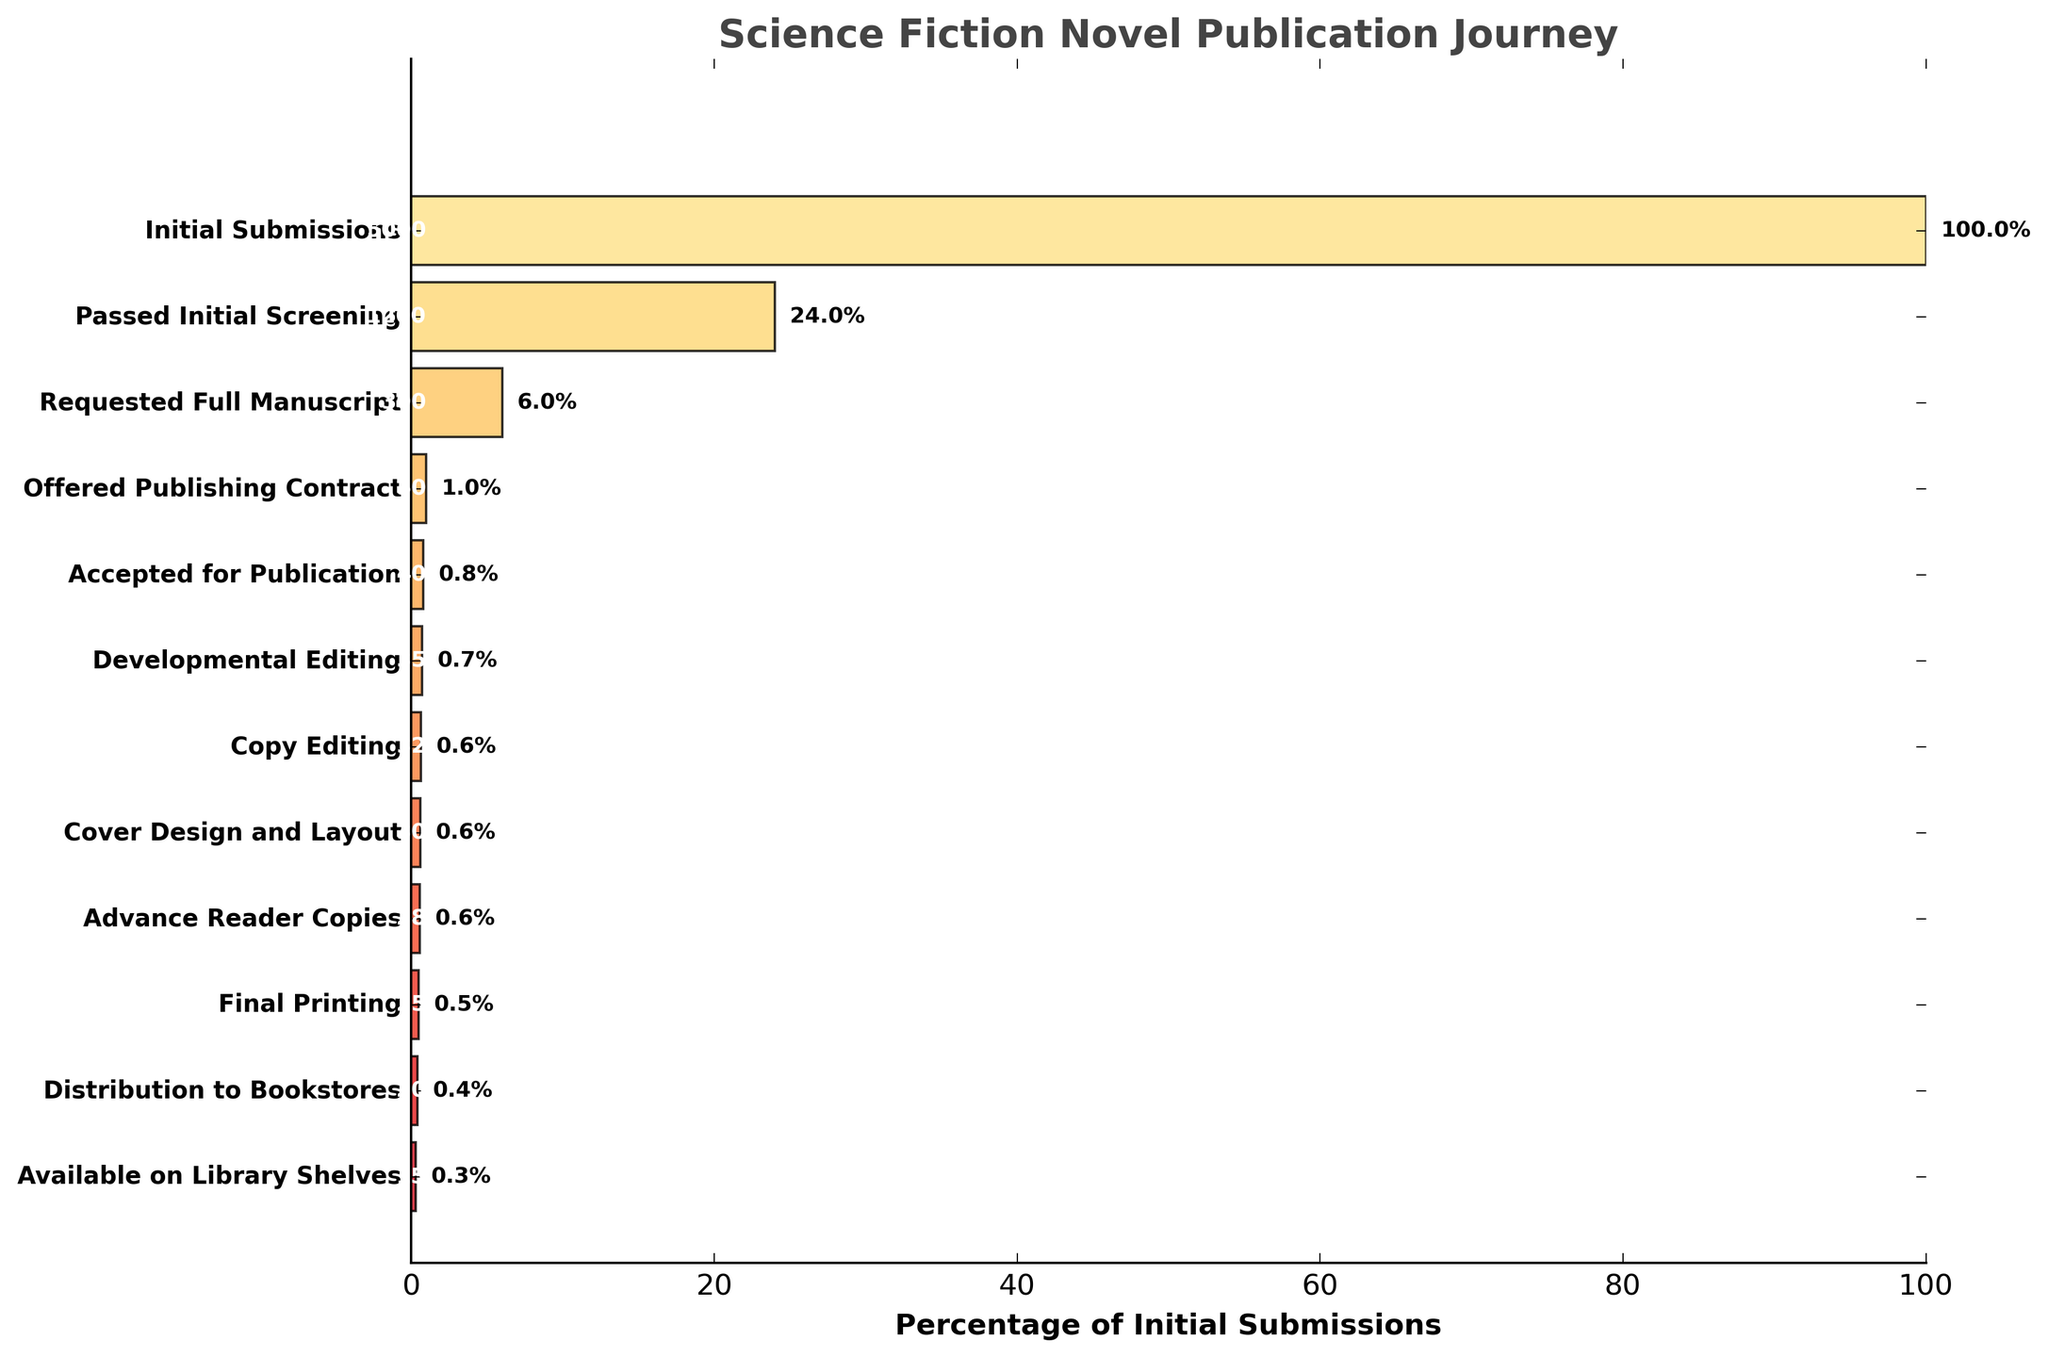What is the title of the plot? The title of the chart is clearly written at the top of the figure. It indicates what the data in the chart represents.
Answer: Science Fiction Novel Publication Journey How many manuscript submissions were there initially? The first stage in the funnel chart shows the initial number of manuscript submissions in the dataset.
Answer: 5000 What is the percentage of manuscripts that reached the Copy Editing stage? Identify the Copy Editing stage and its corresponding percentage from the plotted bars. The value should be visually displayed next to the bar.
Answer: 0.6% How many manuscripts make it to the Final Printing stage? Find the stage labeled "Final Printing" on the chart and read the corresponding number directly from the text displayed on the bar.
Answer: 25 Which stage shows the largest drop in the number of manuscripts? Observe the funnel chart for the largest visual difference between two consecutive stages. Find the stage with the steepest decline.
Answer: Initial Submissions to Passed Initial Screening By what percentage do manuscripts decrease from the Requested Full Manuscript stage to the Contract Offered stage? Calculate the percentage drop from Requested Full Manuscript to Offered Publishing Contract using the numbers provided: ((300 - 50) / 300) * 100.
Answer: 83.3% How many more manuscripts were offered a publishing contract compared to those that reached the Developmental Editing stage? Subtract the number of manuscripts in the Developmental Editing stage from those offered a publishing contract.
Answer: 15 Compare the number of manuscripts in the Cover Design and Layout stage to those in the Advance Reader Copies stage. Which stage has fewer manuscripts? Identify both stages on the chart and compare their numbers directly from the values shown on the bars.
Answer: Advance Reader Copies What portion of the initial manuscript submissions reached the Distribution to Bookstores stage? Calculate the percentage by dividing the number in the Distribution to Bookstores stage by the initial submissions and multiplying by 100: (20 / 5000) * 100.
Answer: 0.4% What is the final percentage of manuscripts that make it to the library shelves? Locate the final stage "Available on Library Shelves" and read the percentage value directly from the funnel chart.
Answer: 0.3% 